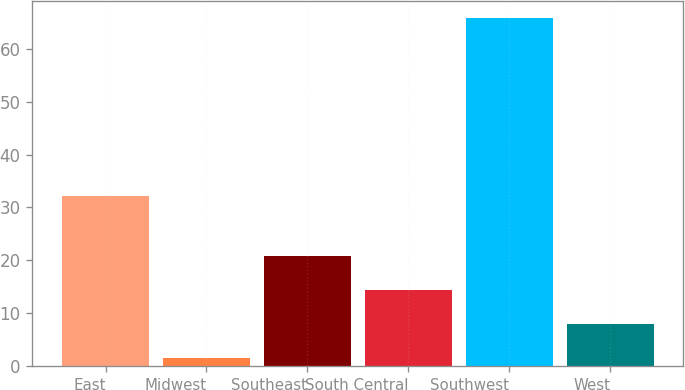Convert chart to OTSL. <chart><loc_0><loc_0><loc_500><loc_500><bar_chart><fcel>East<fcel>Midwest<fcel>Southeast<fcel>South Central<fcel>Southwest<fcel>West<nl><fcel>32.2<fcel>1.5<fcel>20.79<fcel>14.36<fcel>65.8<fcel>7.93<nl></chart> 